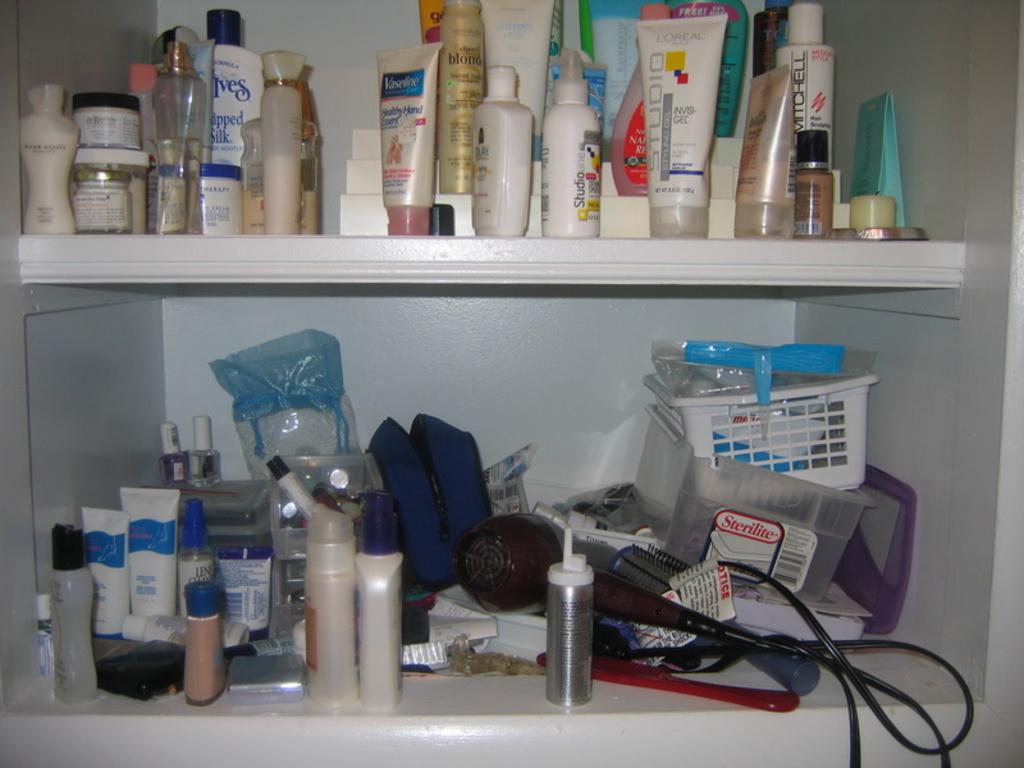What company makes the clear plastic container on the bottom right?
Ensure brevity in your answer.  Sterilite. 